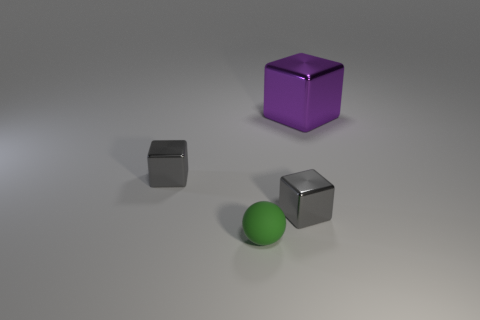Subtract all tiny blocks. How many blocks are left? 1 Subtract all purple blocks. How many blocks are left? 2 Subtract all cubes. How many objects are left? 1 Add 2 large red matte cylinders. How many large red matte cylinders exist? 2 Add 4 big shiny cubes. How many objects exist? 8 Subtract 0 red balls. How many objects are left? 4 Subtract 1 spheres. How many spheres are left? 0 Subtract all yellow spheres. Subtract all purple cubes. How many spheres are left? 1 Subtract all cyan cylinders. How many purple blocks are left? 1 Subtract all tiny green matte balls. Subtract all balls. How many objects are left? 2 